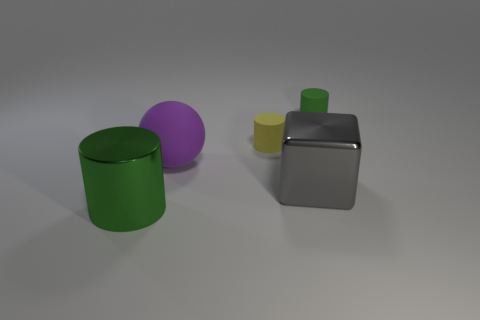There is a thing that is the same size as the yellow rubber cylinder; what is its shape? cylinder 